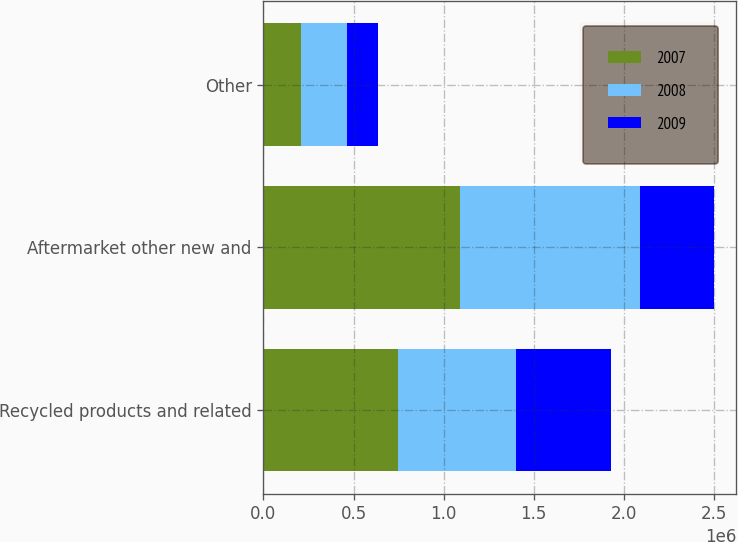<chart> <loc_0><loc_0><loc_500><loc_500><stacked_bar_chart><ecel><fcel>Recycled products and related<fcel>Aftermarket other new and<fcel>Other<nl><fcel>2007<fcel>749012<fcel>1.09316e+06<fcel>205773<nl><fcel>2008<fcel>651803<fcel>998541<fcel>258188<nl><fcel>2009<fcel>530152<fcel>409304<fcel>172895<nl></chart> 